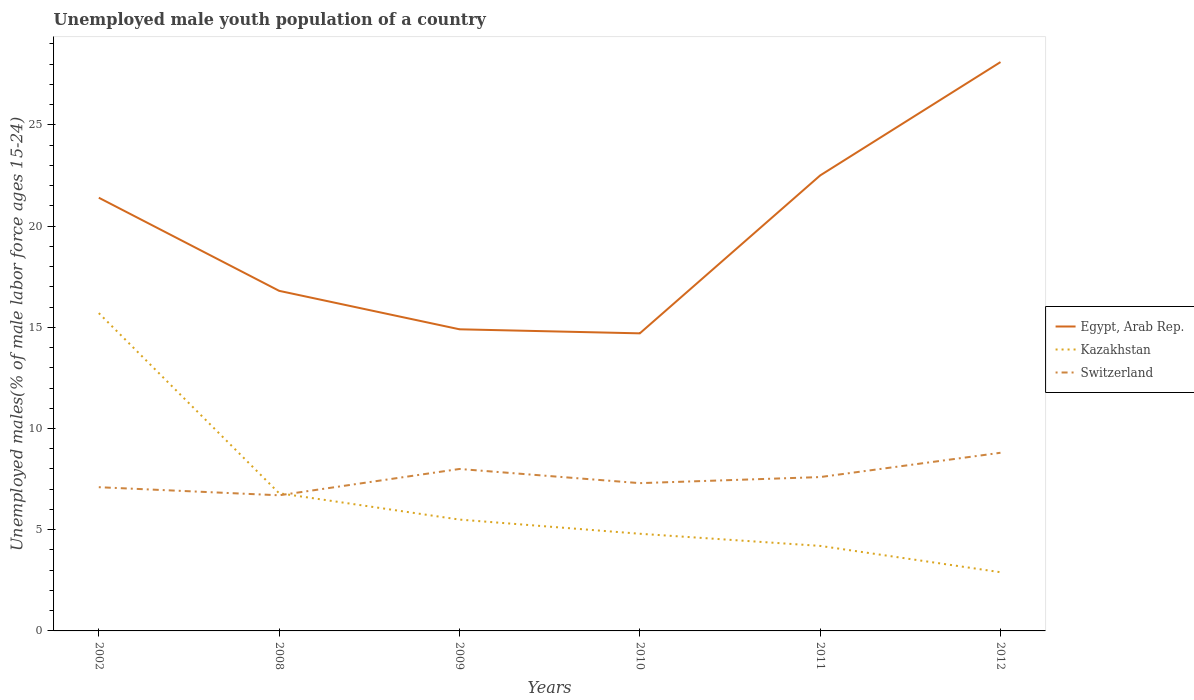How many different coloured lines are there?
Provide a succinct answer. 3. Does the line corresponding to Egypt, Arab Rep. intersect with the line corresponding to Switzerland?
Make the answer very short. No. Across all years, what is the maximum percentage of unemployed male youth population in Switzerland?
Give a very brief answer. 6.7. In which year was the percentage of unemployed male youth population in Switzerland maximum?
Offer a terse response. 2008. What is the total percentage of unemployed male youth population in Kazakhstan in the graph?
Keep it short and to the point. 1.3. What is the difference between the highest and the second highest percentage of unemployed male youth population in Switzerland?
Ensure brevity in your answer.  2.1. How are the legend labels stacked?
Your answer should be very brief. Vertical. What is the title of the graph?
Give a very brief answer. Unemployed male youth population of a country. Does "Tonga" appear as one of the legend labels in the graph?
Make the answer very short. No. What is the label or title of the Y-axis?
Offer a very short reply. Unemployed males(% of male labor force ages 15-24). What is the Unemployed males(% of male labor force ages 15-24) of Egypt, Arab Rep. in 2002?
Keep it short and to the point. 21.4. What is the Unemployed males(% of male labor force ages 15-24) of Kazakhstan in 2002?
Keep it short and to the point. 15.7. What is the Unemployed males(% of male labor force ages 15-24) in Switzerland in 2002?
Keep it short and to the point. 7.1. What is the Unemployed males(% of male labor force ages 15-24) in Egypt, Arab Rep. in 2008?
Ensure brevity in your answer.  16.8. What is the Unemployed males(% of male labor force ages 15-24) in Kazakhstan in 2008?
Make the answer very short. 6.8. What is the Unemployed males(% of male labor force ages 15-24) of Switzerland in 2008?
Provide a short and direct response. 6.7. What is the Unemployed males(% of male labor force ages 15-24) in Egypt, Arab Rep. in 2009?
Keep it short and to the point. 14.9. What is the Unemployed males(% of male labor force ages 15-24) in Egypt, Arab Rep. in 2010?
Your response must be concise. 14.7. What is the Unemployed males(% of male labor force ages 15-24) of Kazakhstan in 2010?
Give a very brief answer. 4.8. What is the Unemployed males(% of male labor force ages 15-24) in Switzerland in 2010?
Offer a very short reply. 7.3. What is the Unemployed males(% of male labor force ages 15-24) of Kazakhstan in 2011?
Ensure brevity in your answer.  4.2. What is the Unemployed males(% of male labor force ages 15-24) of Switzerland in 2011?
Your response must be concise. 7.6. What is the Unemployed males(% of male labor force ages 15-24) in Egypt, Arab Rep. in 2012?
Provide a short and direct response. 28.1. What is the Unemployed males(% of male labor force ages 15-24) of Kazakhstan in 2012?
Provide a short and direct response. 2.9. What is the Unemployed males(% of male labor force ages 15-24) of Switzerland in 2012?
Give a very brief answer. 8.8. Across all years, what is the maximum Unemployed males(% of male labor force ages 15-24) in Egypt, Arab Rep.?
Offer a very short reply. 28.1. Across all years, what is the maximum Unemployed males(% of male labor force ages 15-24) in Kazakhstan?
Make the answer very short. 15.7. Across all years, what is the maximum Unemployed males(% of male labor force ages 15-24) of Switzerland?
Make the answer very short. 8.8. Across all years, what is the minimum Unemployed males(% of male labor force ages 15-24) of Egypt, Arab Rep.?
Offer a terse response. 14.7. Across all years, what is the minimum Unemployed males(% of male labor force ages 15-24) in Kazakhstan?
Provide a succinct answer. 2.9. Across all years, what is the minimum Unemployed males(% of male labor force ages 15-24) in Switzerland?
Your answer should be compact. 6.7. What is the total Unemployed males(% of male labor force ages 15-24) in Egypt, Arab Rep. in the graph?
Offer a terse response. 118.4. What is the total Unemployed males(% of male labor force ages 15-24) of Kazakhstan in the graph?
Provide a succinct answer. 39.9. What is the total Unemployed males(% of male labor force ages 15-24) in Switzerland in the graph?
Provide a succinct answer. 45.5. What is the difference between the Unemployed males(% of male labor force ages 15-24) in Kazakhstan in 2002 and that in 2008?
Offer a terse response. 8.9. What is the difference between the Unemployed males(% of male labor force ages 15-24) of Switzerland in 2002 and that in 2008?
Ensure brevity in your answer.  0.4. What is the difference between the Unemployed males(% of male labor force ages 15-24) in Egypt, Arab Rep. in 2002 and that in 2009?
Make the answer very short. 6.5. What is the difference between the Unemployed males(% of male labor force ages 15-24) of Switzerland in 2002 and that in 2009?
Your response must be concise. -0.9. What is the difference between the Unemployed males(% of male labor force ages 15-24) in Egypt, Arab Rep. in 2002 and that in 2010?
Ensure brevity in your answer.  6.7. What is the difference between the Unemployed males(% of male labor force ages 15-24) of Switzerland in 2002 and that in 2010?
Provide a short and direct response. -0.2. What is the difference between the Unemployed males(% of male labor force ages 15-24) of Egypt, Arab Rep. in 2002 and that in 2011?
Make the answer very short. -1.1. What is the difference between the Unemployed males(% of male labor force ages 15-24) of Switzerland in 2002 and that in 2012?
Provide a succinct answer. -1.7. What is the difference between the Unemployed males(% of male labor force ages 15-24) of Kazakhstan in 2008 and that in 2009?
Keep it short and to the point. 1.3. What is the difference between the Unemployed males(% of male labor force ages 15-24) of Switzerland in 2008 and that in 2009?
Give a very brief answer. -1.3. What is the difference between the Unemployed males(% of male labor force ages 15-24) of Egypt, Arab Rep. in 2008 and that in 2011?
Provide a succinct answer. -5.7. What is the difference between the Unemployed males(% of male labor force ages 15-24) of Kazakhstan in 2008 and that in 2011?
Ensure brevity in your answer.  2.6. What is the difference between the Unemployed males(% of male labor force ages 15-24) in Kazakhstan in 2008 and that in 2012?
Offer a terse response. 3.9. What is the difference between the Unemployed males(% of male labor force ages 15-24) of Kazakhstan in 2009 and that in 2010?
Ensure brevity in your answer.  0.7. What is the difference between the Unemployed males(% of male labor force ages 15-24) of Egypt, Arab Rep. in 2009 and that in 2011?
Your answer should be very brief. -7.6. What is the difference between the Unemployed males(% of male labor force ages 15-24) of Kazakhstan in 2010 and that in 2011?
Offer a very short reply. 0.6. What is the difference between the Unemployed males(% of male labor force ages 15-24) in Egypt, Arab Rep. in 2010 and that in 2012?
Provide a succinct answer. -13.4. What is the difference between the Unemployed males(% of male labor force ages 15-24) of Kazakhstan in 2010 and that in 2012?
Your answer should be very brief. 1.9. What is the difference between the Unemployed males(% of male labor force ages 15-24) of Switzerland in 2010 and that in 2012?
Your answer should be compact. -1.5. What is the difference between the Unemployed males(% of male labor force ages 15-24) in Egypt, Arab Rep. in 2011 and that in 2012?
Make the answer very short. -5.6. What is the difference between the Unemployed males(% of male labor force ages 15-24) in Switzerland in 2011 and that in 2012?
Give a very brief answer. -1.2. What is the difference between the Unemployed males(% of male labor force ages 15-24) in Kazakhstan in 2002 and the Unemployed males(% of male labor force ages 15-24) in Switzerland in 2008?
Give a very brief answer. 9. What is the difference between the Unemployed males(% of male labor force ages 15-24) in Egypt, Arab Rep. in 2002 and the Unemployed males(% of male labor force ages 15-24) in Kazakhstan in 2009?
Make the answer very short. 15.9. What is the difference between the Unemployed males(% of male labor force ages 15-24) of Egypt, Arab Rep. in 2002 and the Unemployed males(% of male labor force ages 15-24) of Switzerland in 2009?
Ensure brevity in your answer.  13.4. What is the difference between the Unemployed males(% of male labor force ages 15-24) of Egypt, Arab Rep. in 2002 and the Unemployed males(% of male labor force ages 15-24) of Kazakhstan in 2010?
Your answer should be compact. 16.6. What is the difference between the Unemployed males(% of male labor force ages 15-24) of Kazakhstan in 2002 and the Unemployed males(% of male labor force ages 15-24) of Switzerland in 2010?
Give a very brief answer. 8.4. What is the difference between the Unemployed males(% of male labor force ages 15-24) in Kazakhstan in 2002 and the Unemployed males(% of male labor force ages 15-24) in Switzerland in 2011?
Provide a short and direct response. 8.1. What is the difference between the Unemployed males(% of male labor force ages 15-24) in Egypt, Arab Rep. in 2002 and the Unemployed males(% of male labor force ages 15-24) in Switzerland in 2012?
Make the answer very short. 12.6. What is the difference between the Unemployed males(% of male labor force ages 15-24) in Kazakhstan in 2002 and the Unemployed males(% of male labor force ages 15-24) in Switzerland in 2012?
Give a very brief answer. 6.9. What is the difference between the Unemployed males(% of male labor force ages 15-24) of Egypt, Arab Rep. in 2008 and the Unemployed males(% of male labor force ages 15-24) of Switzerland in 2009?
Offer a terse response. 8.8. What is the difference between the Unemployed males(% of male labor force ages 15-24) of Egypt, Arab Rep. in 2008 and the Unemployed males(% of male labor force ages 15-24) of Kazakhstan in 2010?
Offer a very short reply. 12. What is the difference between the Unemployed males(% of male labor force ages 15-24) in Egypt, Arab Rep. in 2008 and the Unemployed males(% of male labor force ages 15-24) in Switzerland in 2010?
Offer a terse response. 9.5. What is the difference between the Unemployed males(% of male labor force ages 15-24) of Kazakhstan in 2008 and the Unemployed males(% of male labor force ages 15-24) of Switzerland in 2010?
Your answer should be very brief. -0.5. What is the difference between the Unemployed males(% of male labor force ages 15-24) of Egypt, Arab Rep. in 2008 and the Unemployed males(% of male labor force ages 15-24) of Kazakhstan in 2011?
Your answer should be very brief. 12.6. What is the difference between the Unemployed males(% of male labor force ages 15-24) in Egypt, Arab Rep. in 2008 and the Unemployed males(% of male labor force ages 15-24) in Switzerland in 2011?
Make the answer very short. 9.2. What is the difference between the Unemployed males(% of male labor force ages 15-24) of Egypt, Arab Rep. in 2008 and the Unemployed males(% of male labor force ages 15-24) of Kazakhstan in 2012?
Make the answer very short. 13.9. What is the difference between the Unemployed males(% of male labor force ages 15-24) of Egypt, Arab Rep. in 2008 and the Unemployed males(% of male labor force ages 15-24) of Switzerland in 2012?
Offer a terse response. 8. What is the difference between the Unemployed males(% of male labor force ages 15-24) of Egypt, Arab Rep. in 2009 and the Unemployed males(% of male labor force ages 15-24) of Switzerland in 2010?
Offer a very short reply. 7.6. What is the difference between the Unemployed males(% of male labor force ages 15-24) in Kazakhstan in 2009 and the Unemployed males(% of male labor force ages 15-24) in Switzerland in 2010?
Offer a terse response. -1.8. What is the difference between the Unemployed males(% of male labor force ages 15-24) in Egypt, Arab Rep. in 2009 and the Unemployed males(% of male labor force ages 15-24) in Kazakhstan in 2011?
Keep it short and to the point. 10.7. What is the difference between the Unemployed males(% of male labor force ages 15-24) of Egypt, Arab Rep. in 2009 and the Unemployed males(% of male labor force ages 15-24) of Switzerland in 2011?
Make the answer very short. 7.3. What is the difference between the Unemployed males(% of male labor force ages 15-24) of Egypt, Arab Rep. in 2010 and the Unemployed males(% of male labor force ages 15-24) of Switzerland in 2011?
Your answer should be compact. 7.1. What is the difference between the Unemployed males(% of male labor force ages 15-24) in Kazakhstan in 2010 and the Unemployed males(% of male labor force ages 15-24) in Switzerland in 2012?
Offer a terse response. -4. What is the difference between the Unemployed males(% of male labor force ages 15-24) in Egypt, Arab Rep. in 2011 and the Unemployed males(% of male labor force ages 15-24) in Kazakhstan in 2012?
Provide a succinct answer. 19.6. What is the difference between the Unemployed males(% of male labor force ages 15-24) of Egypt, Arab Rep. in 2011 and the Unemployed males(% of male labor force ages 15-24) of Switzerland in 2012?
Your answer should be compact. 13.7. What is the average Unemployed males(% of male labor force ages 15-24) in Egypt, Arab Rep. per year?
Your response must be concise. 19.73. What is the average Unemployed males(% of male labor force ages 15-24) of Kazakhstan per year?
Make the answer very short. 6.65. What is the average Unemployed males(% of male labor force ages 15-24) of Switzerland per year?
Make the answer very short. 7.58. In the year 2002, what is the difference between the Unemployed males(% of male labor force ages 15-24) of Kazakhstan and Unemployed males(% of male labor force ages 15-24) of Switzerland?
Keep it short and to the point. 8.6. In the year 2008, what is the difference between the Unemployed males(% of male labor force ages 15-24) of Egypt, Arab Rep. and Unemployed males(% of male labor force ages 15-24) of Switzerland?
Give a very brief answer. 10.1. In the year 2009, what is the difference between the Unemployed males(% of male labor force ages 15-24) in Egypt, Arab Rep. and Unemployed males(% of male labor force ages 15-24) in Kazakhstan?
Your response must be concise. 9.4. In the year 2009, what is the difference between the Unemployed males(% of male labor force ages 15-24) of Kazakhstan and Unemployed males(% of male labor force ages 15-24) of Switzerland?
Keep it short and to the point. -2.5. In the year 2010, what is the difference between the Unemployed males(% of male labor force ages 15-24) of Egypt, Arab Rep. and Unemployed males(% of male labor force ages 15-24) of Kazakhstan?
Your answer should be compact. 9.9. In the year 2010, what is the difference between the Unemployed males(% of male labor force ages 15-24) of Kazakhstan and Unemployed males(% of male labor force ages 15-24) of Switzerland?
Give a very brief answer. -2.5. In the year 2011, what is the difference between the Unemployed males(% of male labor force ages 15-24) in Egypt, Arab Rep. and Unemployed males(% of male labor force ages 15-24) in Switzerland?
Offer a very short reply. 14.9. In the year 2011, what is the difference between the Unemployed males(% of male labor force ages 15-24) in Kazakhstan and Unemployed males(% of male labor force ages 15-24) in Switzerland?
Your answer should be compact. -3.4. In the year 2012, what is the difference between the Unemployed males(% of male labor force ages 15-24) in Egypt, Arab Rep. and Unemployed males(% of male labor force ages 15-24) in Kazakhstan?
Give a very brief answer. 25.2. In the year 2012, what is the difference between the Unemployed males(% of male labor force ages 15-24) of Egypt, Arab Rep. and Unemployed males(% of male labor force ages 15-24) of Switzerland?
Your response must be concise. 19.3. In the year 2012, what is the difference between the Unemployed males(% of male labor force ages 15-24) in Kazakhstan and Unemployed males(% of male labor force ages 15-24) in Switzerland?
Offer a terse response. -5.9. What is the ratio of the Unemployed males(% of male labor force ages 15-24) in Egypt, Arab Rep. in 2002 to that in 2008?
Provide a short and direct response. 1.27. What is the ratio of the Unemployed males(% of male labor force ages 15-24) in Kazakhstan in 2002 to that in 2008?
Keep it short and to the point. 2.31. What is the ratio of the Unemployed males(% of male labor force ages 15-24) of Switzerland in 2002 to that in 2008?
Provide a succinct answer. 1.06. What is the ratio of the Unemployed males(% of male labor force ages 15-24) of Egypt, Arab Rep. in 2002 to that in 2009?
Your response must be concise. 1.44. What is the ratio of the Unemployed males(% of male labor force ages 15-24) of Kazakhstan in 2002 to that in 2009?
Ensure brevity in your answer.  2.85. What is the ratio of the Unemployed males(% of male labor force ages 15-24) of Switzerland in 2002 to that in 2009?
Keep it short and to the point. 0.89. What is the ratio of the Unemployed males(% of male labor force ages 15-24) in Egypt, Arab Rep. in 2002 to that in 2010?
Your response must be concise. 1.46. What is the ratio of the Unemployed males(% of male labor force ages 15-24) in Kazakhstan in 2002 to that in 2010?
Offer a very short reply. 3.27. What is the ratio of the Unemployed males(% of male labor force ages 15-24) in Switzerland in 2002 to that in 2010?
Your response must be concise. 0.97. What is the ratio of the Unemployed males(% of male labor force ages 15-24) of Egypt, Arab Rep. in 2002 to that in 2011?
Offer a very short reply. 0.95. What is the ratio of the Unemployed males(% of male labor force ages 15-24) in Kazakhstan in 2002 to that in 2011?
Give a very brief answer. 3.74. What is the ratio of the Unemployed males(% of male labor force ages 15-24) of Switzerland in 2002 to that in 2011?
Provide a succinct answer. 0.93. What is the ratio of the Unemployed males(% of male labor force ages 15-24) of Egypt, Arab Rep. in 2002 to that in 2012?
Provide a succinct answer. 0.76. What is the ratio of the Unemployed males(% of male labor force ages 15-24) in Kazakhstan in 2002 to that in 2012?
Your answer should be compact. 5.41. What is the ratio of the Unemployed males(% of male labor force ages 15-24) in Switzerland in 2002 to that in 2012?
Keep it short and to the point. 0.81. What is the ratio of the Unemployed males(% of male labor force ages 15-24) in Egypt, Arab Rep. in 2008 to that in 2009?
Your answer should be very brief. 1.13. What is the ratio of the Unemployed males(% of male labor force ages 15-24) of Kazakhstan in 2008 to that in 2009?
Give a very brief answer. 1.24. What is the ratio of the Unemployed males(% of male labor force ages 15-24) in Switzerland in 2008 to that in 2009?
Provide a succinct answer. 0.84. What is the ratio of the Unemployed males(% of male labor force ages 15-24) in Egypt, Arab Rep. in 2008 to that in 2010?
Ensure brevity in your answer.  1.14. What is the ratio of the Unemployed males(% of male labor force ages 15-24) in Kazakhstan in 2008 to that in 2010?
Provide a succinct answer. 1.42. What is the ratio of the Unemployed males(% of male labor force ages 15-24) of Switzerland in 2008 to that in 2010?
Keep it short and to the point. 0.92. What is the ratio of the Unemployed males(% of male labor force ages 15-24) of Egypt, Arab Rep. in 2008 to that in 2011?
Provide a short and direct response. 0.75. What is the ratio of the Unemployed males(% of male labor force ages 15-24) of Kazakhstan in 2008 to that in 2011?
Offer a terse response. 1.62. What is the ratio of the Unemployed males(% of male labor force ages 15-24) in Switzerland in 2008 to that in 2011?
Keep it short and to the point. 0.88. What is the ratio of the Unemployed males(% of male labor force ages 15-24) of Egypt, Arab Rep. in 2008 to that in 2012?
Your answer should be compact. 0.6. What is the ratio of the Unemployed males(% of male labor force ages 15-24) of Kazakhstan in 2008 to that in 2012?
Your answer should be compact. 2.34. What is the ratio of the Unemployed males(% of male labor force ages 15-24) of Switzerland in 2008 to that in 2012?
Provide a succinct answer. 0.76. What is the ratio of the Unemployed males(% of male labor force ages 15-24) in Egypt, Arab Rep. in 2009 to that in 2010?
Make the answer very short. 1.01. What is the ratio of the Unemployed males(% of male labor force ages 15-24) of Kazakhstan in 2009 to that in 2010?
Your answer should be compact. 1.15. What is the ratio of the Unemployed males(% of male labor force ages 15-24) of Switzerland in 2009 to that in 2010?
Your answer should be very brief. 1.1. What is the ratio of the Unemployed males(% of male labor force ages 15-24) in Egypt, Arab Rep. in 2009 to that in 2011?
Offer a very short reply. 0.66. What is the ratio of the Unemployed males(% of male labor force ages 15-24) in Kazakhstan in 2009 to that in 2011?
Ensure brevity in your answer.  1.31. What is the ratio of the Unemployed males(% of male labor force ages 15-24) of Switzerland in 2009 to that in 2011?
Provide a succinct answer. 1.05. What is the ratio of the Unemployed males(% of male labor force ages 15-24) of Egypt, Arab Rep. in 2009 to that in 2012?
Provide a short and direct response. 0.53. What is the ratio of the Unemployed males(% of male labor force ages 15-24) of Kazakhstan in 2009 to that in 2012?
Provide a succinct answer. 1.9. What is the ratio of the Unemployed males(% of male labor force ages 15-24) of Switzerland in 2009 to that in 2012?
Your answer should be very brief. 0.91. What is the ratio of the Unemployed males(% of male labor force ages 15-24) in Egypt, Arab Rep. in 2010 to that in 2011?
Your answer should be compact. 0.65. What is the ratio of the Unemployed males(% of male labor force ages 15-24) in Kazakhstan in 2010 to that in 2011?
Your response must be concise. 1.14. What is the ratio of the Unemployed males(% of male labor force ages 15-24) in Switzerland in 2010 to that in 2011?
Keep it short and to the point. 0.96. What is the ratio of the Unemployed males(% of male labor force ages 15-24) of Egypt, Arab Rep. in 2010 to that in 2012?
Keep it short and to the point. 0.52. What is the ratio of the Unemployed males(% of male labor force ages 15-24) in Kazakhstan in 2010 to that in 2012?
Ensure brevity in your answer.  1.66. What is the ratio of the Unemployed males(% of male labor force ages 15-24) in Switzerland in 2010 to that in 2012?
Provide a short and direct response. 0.83. What is the ratio of the Unemployed males(% of male labor force ages 15-24) of Egypt, Arab Rep. in 2011 to that in 2012?
Offer a terse response. 0.8. What is the ratio of the Unemployed males(% of male labor force ages 15-24) in Kazakhstan in 2011 to that in 2012?
Provide a succinct answer. 1.45. What is the ratio of the Unemployed males(% of male labor force ages 15-24) of Switzerland in 2011 to that in 2012?
Provide a short and direct response. 0.86. What is the difference between the highest and the lowest Unemployed males(% of male labor force ages 15-24) of Egypt, Arab Rep.?
Make the answer very short. 13.4. What is the difference between the highest and the lowest Unemployed males(% of male labor force ages 15-24) in Kazakhstan?
Make the answer very short. 12.8. 